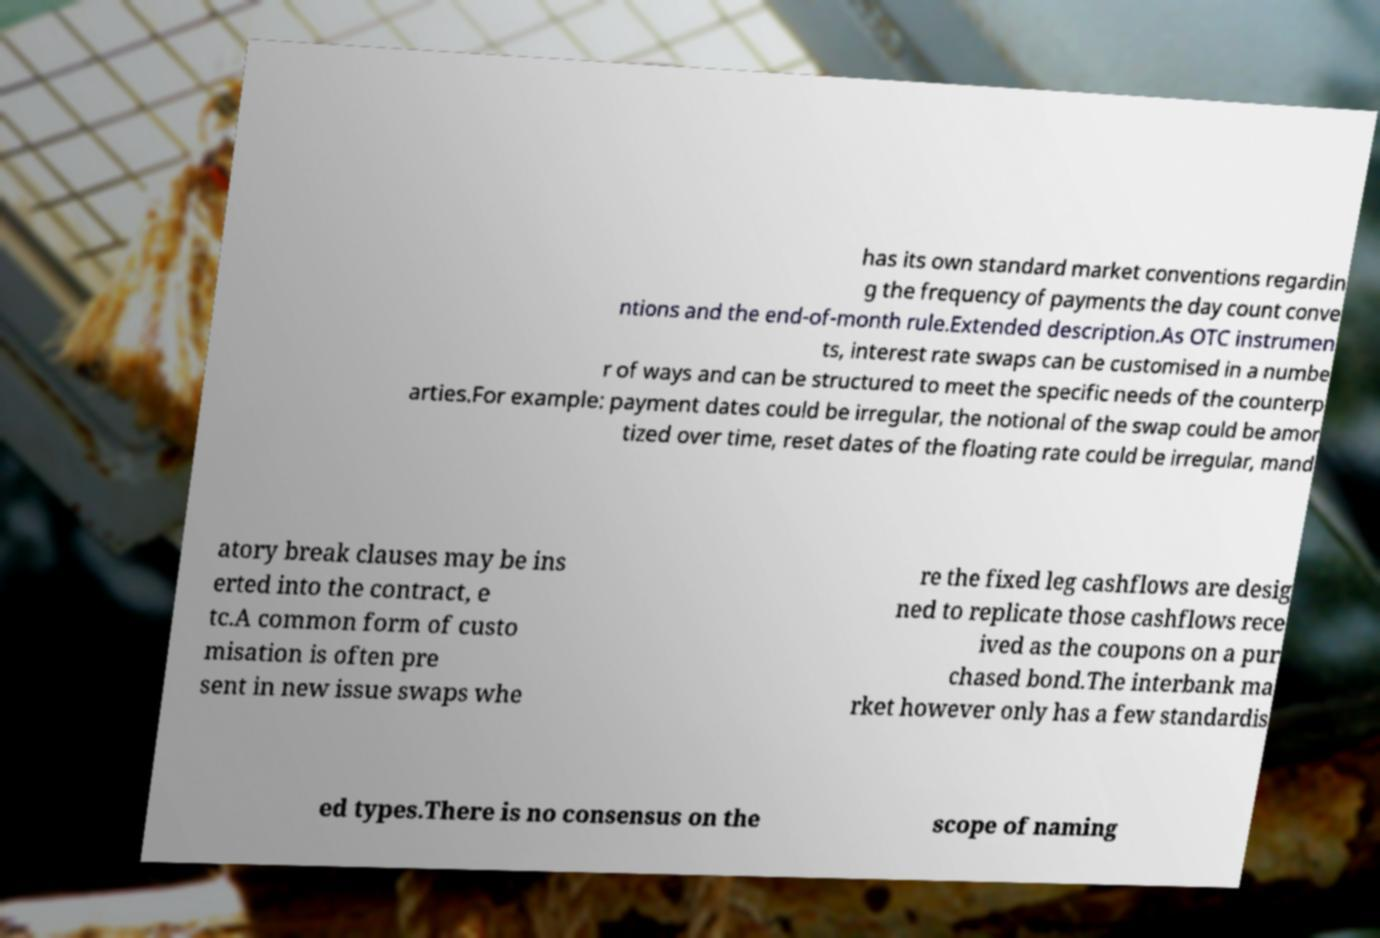Could you assist in decoding the text presented in this image and type it out clearly? has its own standard market conventions regardin g the frequency of payments the day count conve ntions and the end-of-month rule.Extended description.As OTC instrumen ts, interest rate swaps can be customised in a numbe r of ways and can be structured to meet the specific needs of the counterp arties.For example: payment dates could be irregular, the notional of the swap could be amor tized over time, reset dates of the floating rate could be irregular, mand atory break clauses may be ins erted into the contract, e tc.A common form of custo misation is often pre sent in new issue swaps whe re the fixed leg cashflows are desig ned to replicate those cashflows rece ived as the coupons on a pur chased bond.The interbank ma rket however only has a few standardis ed types.There is no consensus on the scope of naming 